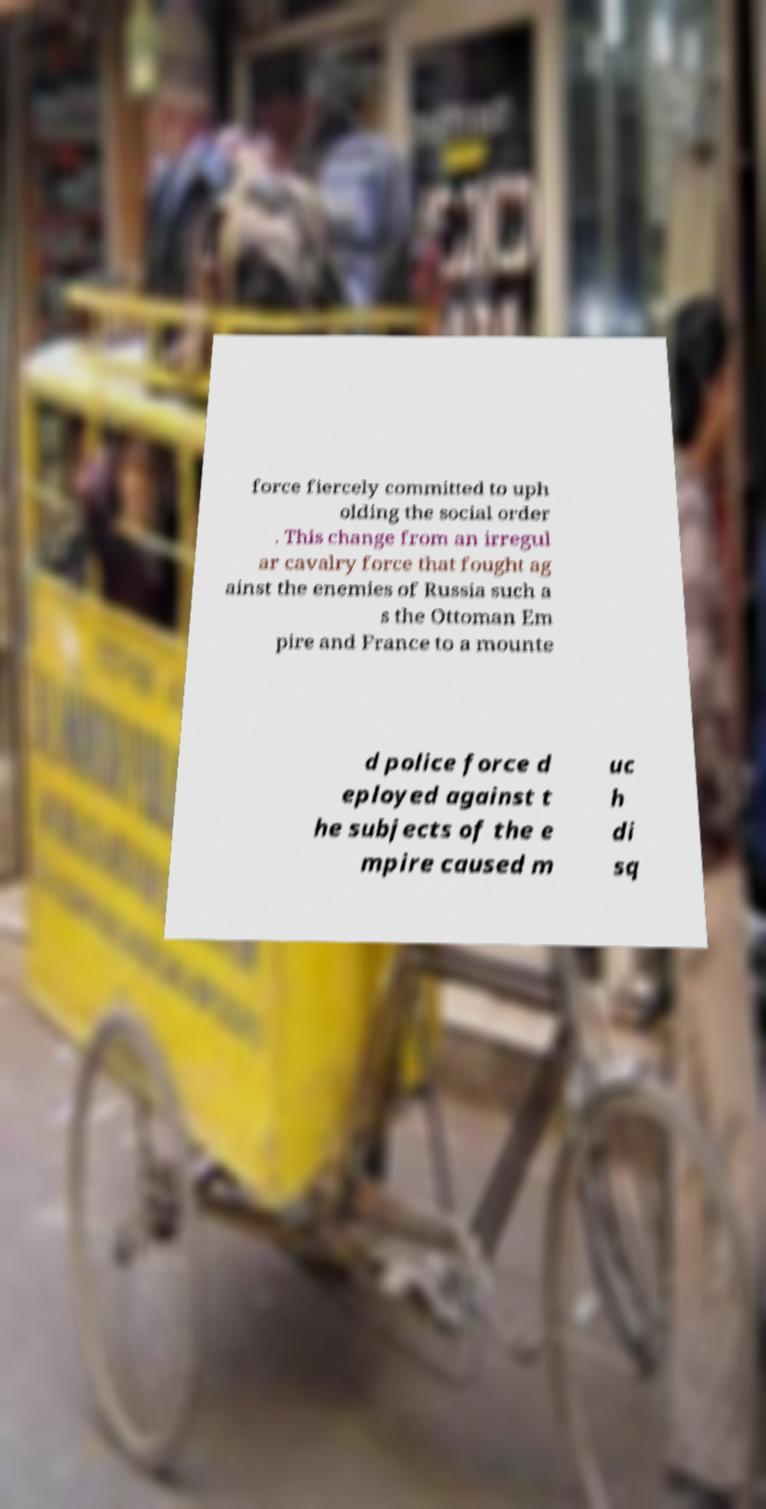Can you accurately transcribe the text from the provided image for me? force fiercely committed to uph olding the social order . This change from an irregul ar cavalry force that fought ag ainst the enemies of Russia such a s the Ottoman Em pire and France to a mounte d police force d eployed against t he subjects of the e mpire caused m uc h di sq 